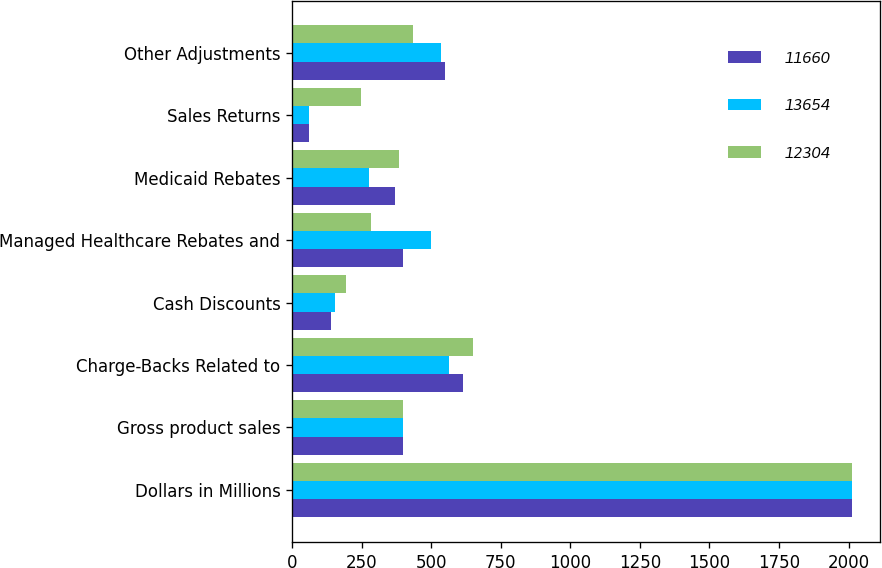<chart> <loc_0><loc_0><loc_500><loc_500><stacked_bar_chart><ecel><fcel>Dollars in Millions<fcel>Gross product sales<fcel>Charge-Backs Related to<fcel>Cash Discounts<fcel>Managed Healthcare Rebates and<fcel>Medicaid Rebates<fcel>Sales Returns<fcel>Other Adjustments<nl><fcel>11660<fcel>2014<fcel>399<fcel>614<fcel>141<fcel>399<fcel>370<fcel>61<fcel>548<nl><fcel>13654<fcel>2013<fcel>399<fcel>563<fcel>154<fcel>499<fcel>275<fcel>62<fcel>534<nl><fcel>12304<fcel>2012<fcel>399<fcel>651<fcel>192<fcel>284<fcel>386<fcel>248<fcel>434<nl></chart> 